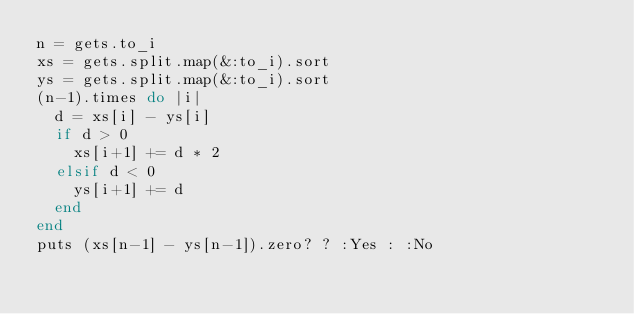Convert code to text. <code><loc_0><loc_0><loc_500><loc_500><_Ruby_>n = gets.to_i
xs = gets.split.map(&:to_i).sort
ys = gets.split.map(&:to_i).sort
(n-1).times do |i|
  d = xs[i] - ys[i]
  if d > 0
    xs[i+1] += d * 2
  elsif d < 0
    ys[i+1] += d
  end
end
puts (xs[n-1] - ys[n-1]).zero? ? :Yes : :No
</code> 